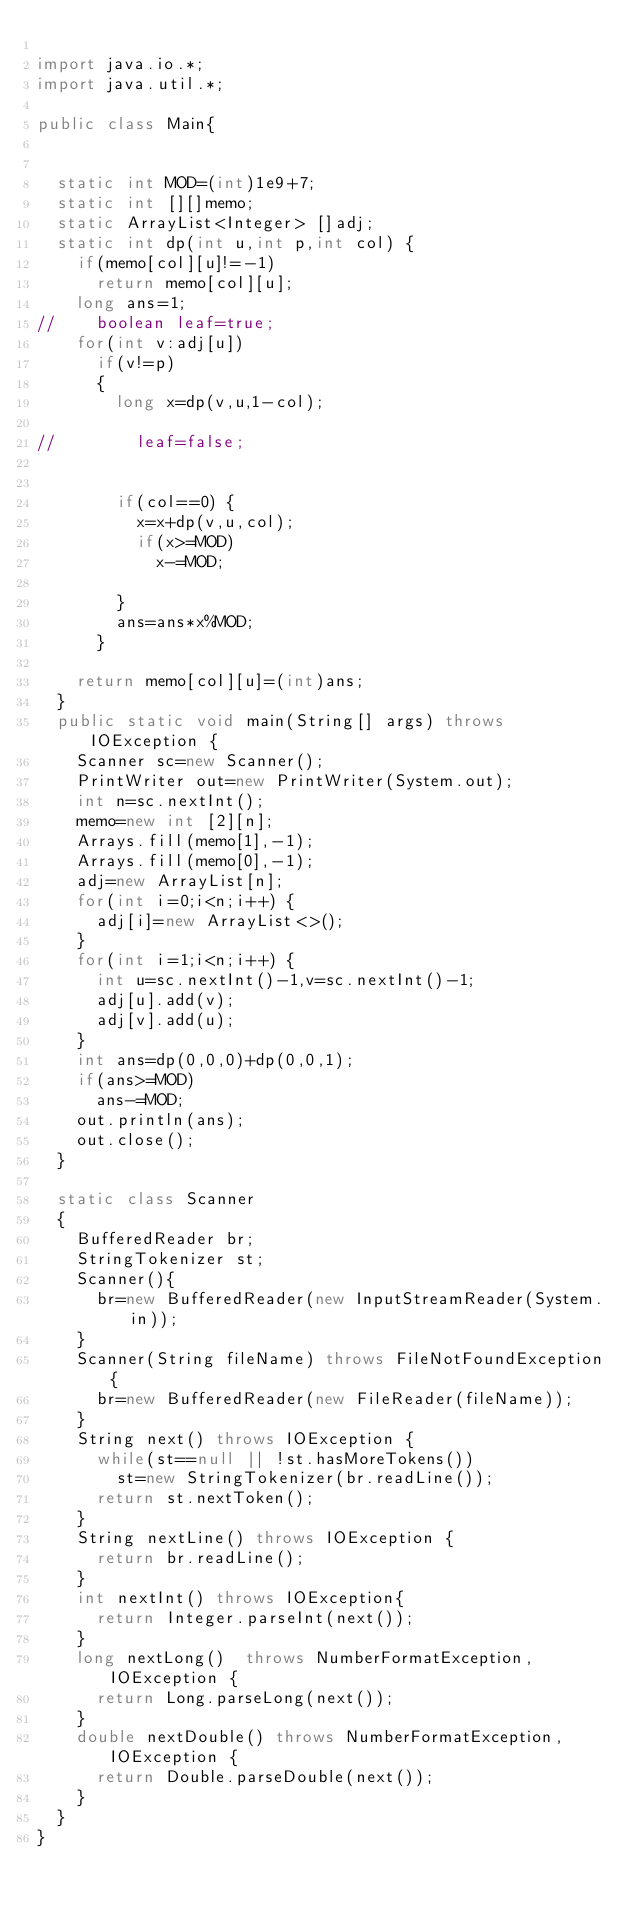Convert code to text. <code><loc_0><loc_0><loc_500><loc_500><_Java_>
import java.io.*;
import java.util.*;

public class Main{

	
	static int MOD=(int)1e9+7;
	static int [][]memo;
	static ArrayList<Integer> []adj;
	static int dp(int u,int p,int col) {
		if(memo[col][u]!=-1)
			return memo[col][u];
		long ans=1;
//		boolean leaf=true;
		for(int v:adj[u])
			if(v!=p)
			{
				long x=dp(v,u,1-col);
				
//				leaf=false;
				
				
				if(col==0) {
					x=x+dp(v,u,col);
					if(x>=MOD)
						x-=MOD;
					
				}
				ans=ans*x%MOD;
			}
		
		return memo[col][u]=(int)ans;
	}
	public static void main(String[] args) throws IOException {
		Scanner sc=new Scanner();
		PrintWriter out=new PrintWriter(System.out);
		int n=sc.nextInt();
		memo=new int [2][n];
		Arrays.fill(memo[1],-1);
		Arrays.fill(memo[0],-1);
		adj=new ArrayList[n];
		for(int i=0;i<n;i++) {
			adj[i]=new ArrayList<>();
		}
		for(int i=1;i<n;i++) {
			int u=sc.nextInt()-1,v=sc.nextInt()-1;
			adj[u].add(v);
			adj[v].add(u);
		}
		int ans=dp(0,0,0)+dp(0,0,1);
		if(ans>=MOD)
			ans-=MOD;
		out.println(ans);
		out.close();
	}
	
	static class Scanner
	{
		BufferedReader br;
		StringTokenizer st;
		Scanner(){
			br=new BufferedReader(new InputStreamReader(System.in));
		}
		Scanner(String fileName) throws FileNotFoundException{
			br=new BufferedReader(new FileReader(fileName));
		}
		String next() throws IOException {
			while(st==null || !st.hasMoreTokens())
				st=new StringTokenizer(br.readLine());
			return st.nextToken();
		}
		String nextLine() throws IOException {
			return br.readLine();
		}
		int nextInt() throws IOException{
			return Integer.parseInt(next());
		}
		long nextLong()  throws NumberFormatException, IOException {
			return Long.parseLong(next());
		}
		double nextDouble() throws NumberFormatException, IOException {
			return Double.parseDouble(next());
		}
	}
}
</code> 